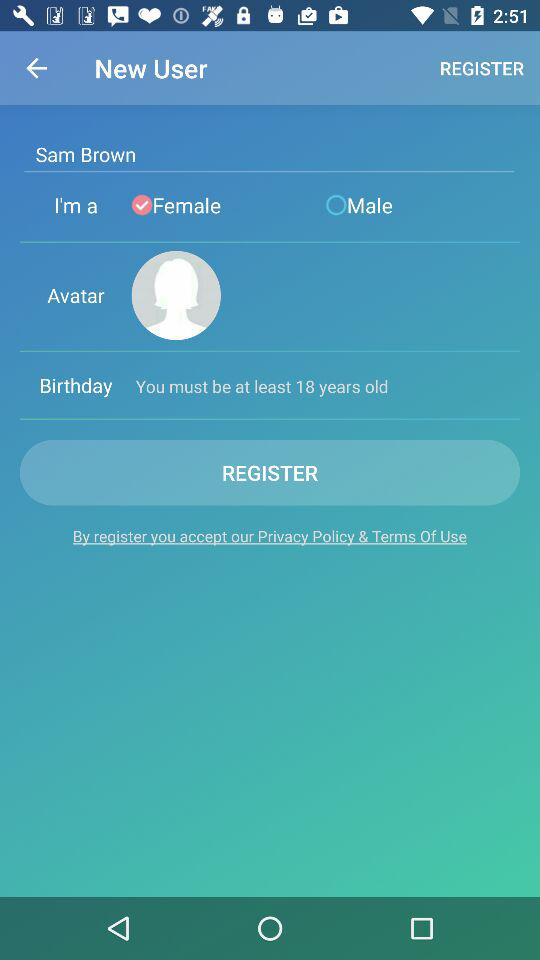What is the selected gender? The selected gender is female. 